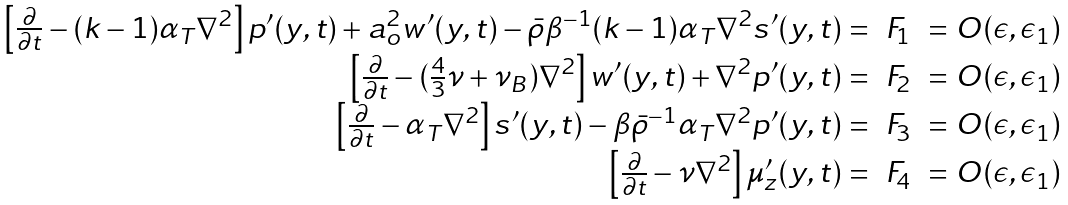Convert formula to latex. <formula><loc_0><loc_0><loc_500><loc_500>\begin{array} { r c l } \left [ \frac { \partial } { \partial t } - ( k - 1 ) \alpha _ { T } \nabla ^ { 2 } \right ] p ^ { \prime } ( y , t ) + a _ { o } ^ { 2 } w ^ { \prime } ( y , t ) - \bar { \rho } \beta ^ { - 1 } ( k - 1 ) \alpha _ { T } \nabla ^ { 2 } s ^ { \prime } ( y , t ) = & F _ { 1 } & = O ( \epsilon , \epsilon _ { 1 } ) \\ \left [ \frac { \partial } { \partial t } - ( \frac { 4 } { 3 } \nu + \nu _ { B } ) \nabla ^ { 2 } \right ] w ^ { \prime } ( y , t ) + \nabla ^ { 2 } p ^ { \prime } ( y , t ) = & F _ { 2 } & = O ( \epsilon , \epsilon _ { 1 } ) \\ \left [ \frac { \partial } { \partial t } - \alpha _ { T } \nabla ^ { 2 } \right ] s ^ { \prime } ( y , t ) - \beta \bar { \rho } ^ { - 1 } \alpha _ { T } \nabla ^ { 2 } p ^ { \prime } ( y , t ) = & F _ { 3 } & = O ( \epsilon , \epsilon _ { 1 } ) \\ \left [ \frac { \partial } { \partial t } - \nu \nabla ^ { 2 } \right ] \mu _ { z } ^ { \prime } ( y , t ) = & F _ { 4 } & = O ( \epsilon , \epsilon _ { 1 } ) \end{array}</formula> 